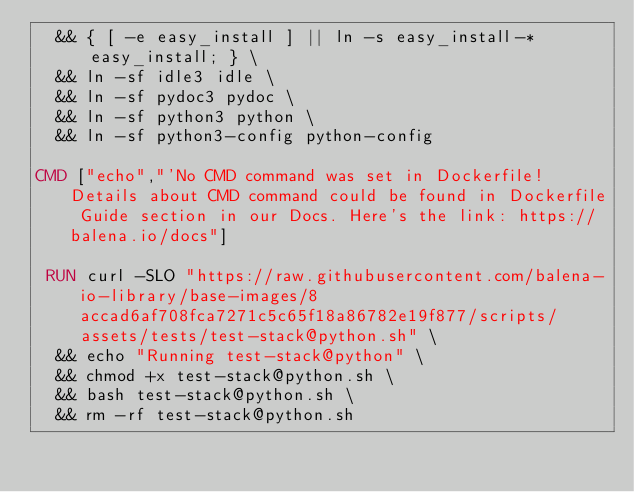<code> <loc_0><loc_0><loc_500><loc_500><_Dockerfile_>	&& { [ -e easy_install ] || ln -s easy_install-* easy_install; } \
	&& ln -sf idle3 idle \
	&& ln -sf pydoc3 pydoc \
	&& ln -sf python3 python \
	&& ln -sf python3-config python-config

CMD ["echo","'No CMD command was set in Dockerfile! Details about CMD command could be found in Dockerfile Guide section in our Docs. Here's the link: https://balena.io/docs"]

 RUN curl -SLO "https://raw.githubusercontent.com/balena-io-library/base-images/8accad6af708fca7271c5c65f18a86782e19f877/scripts/assets/tests/test-stack@python.sh" \
  && echo "Running test-stack@python" \
  && chmod +x test-stack@python.sh \
  && bash test-stack@python.sh \
  && rm -rf test-stack@python.sh 
</code> 